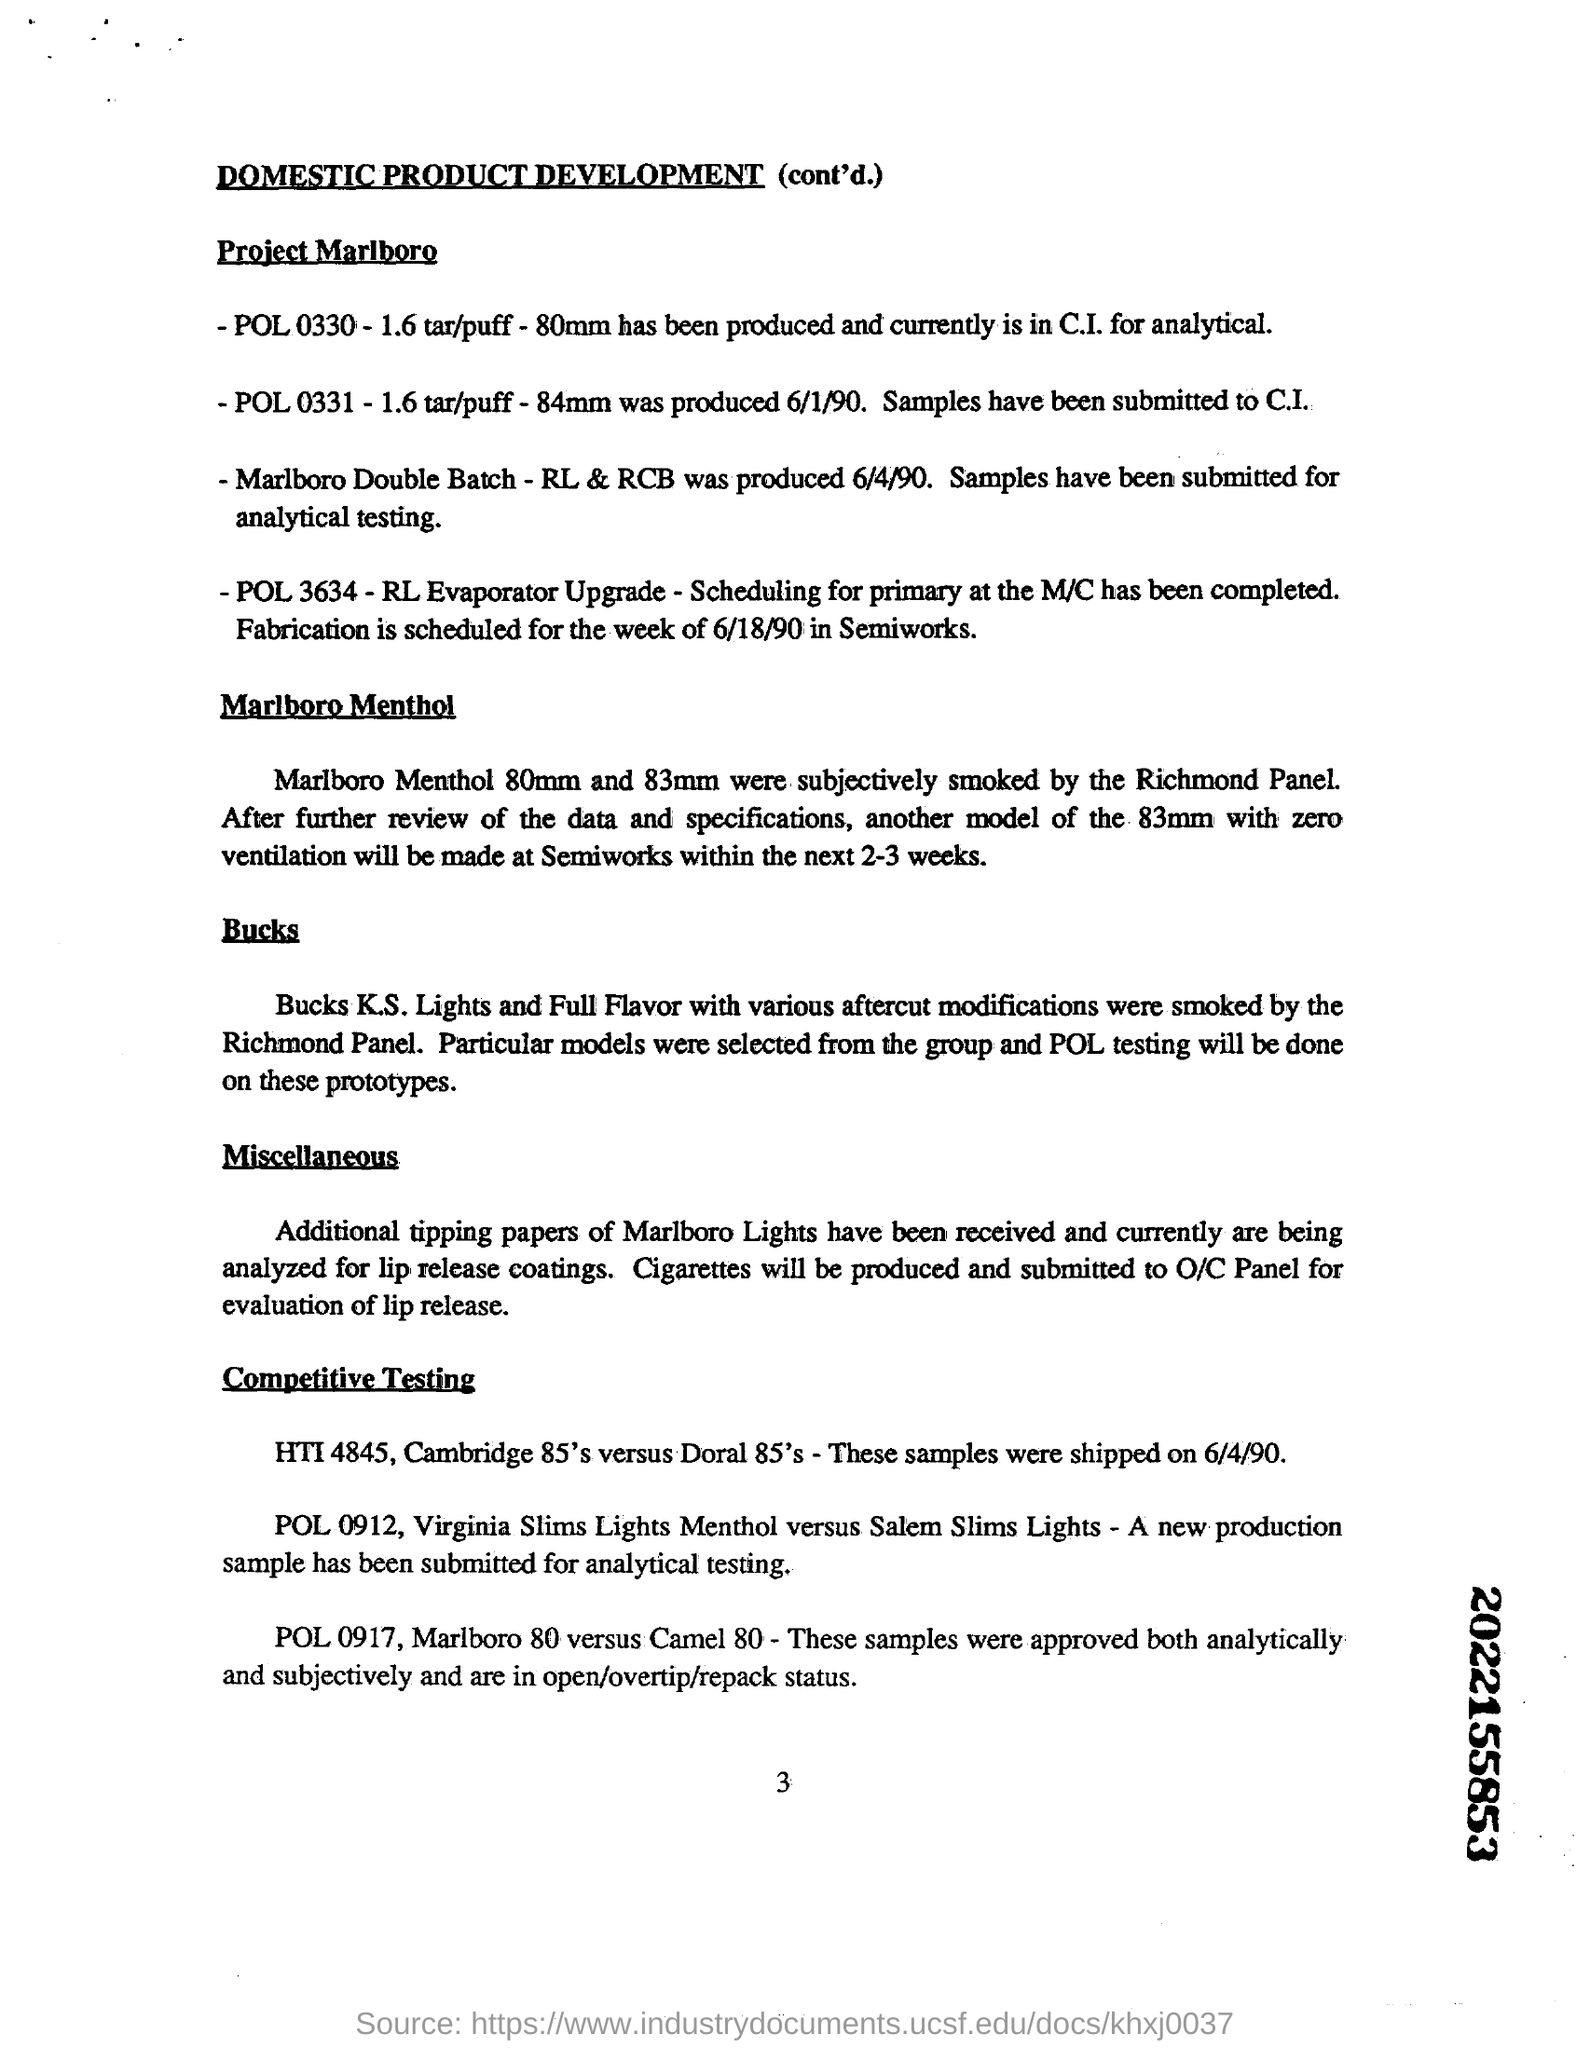What is the significance of comparing the Marlboro 80 with Camel 80 as seen in the document? Comparative testing between Marlboro 80 and Camel 80 aims to assess which brand offers better performance in terms of flavor, draw, and overall consumer satisfaction. This information is crucial for competitive positioning and marketing strategies. 